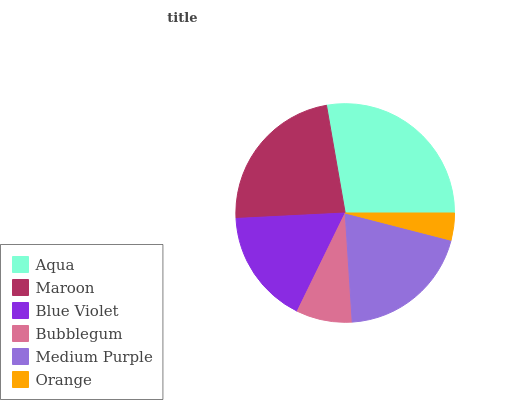Is Orange the minimum?
Answer yes or no. Yes. Is Aqua the maximum?
Answer yes or no. Yes. Is Maroon the minimum?
Answer yes or no. No. Is Maroon the maximum?
Answer yes or no. No. Is Aqua greater than Maroon?
Answer yes or no. Yes. Is Maroon less than Aqua?
Answer yes or no. Yes. Is Maroon greater than Aqua?
Answer yes or no. No. Is Aqua less than Maroon?
Answer yes or no. No. Is Medium Purple the high median?
Answer yes or no. Yes. Is Blue Violet the low median?
Answer yes or no. Yes. Is Orange the high median?
Answer yes or no. No. Is Orange the low median?
Answer yes or no. No. 